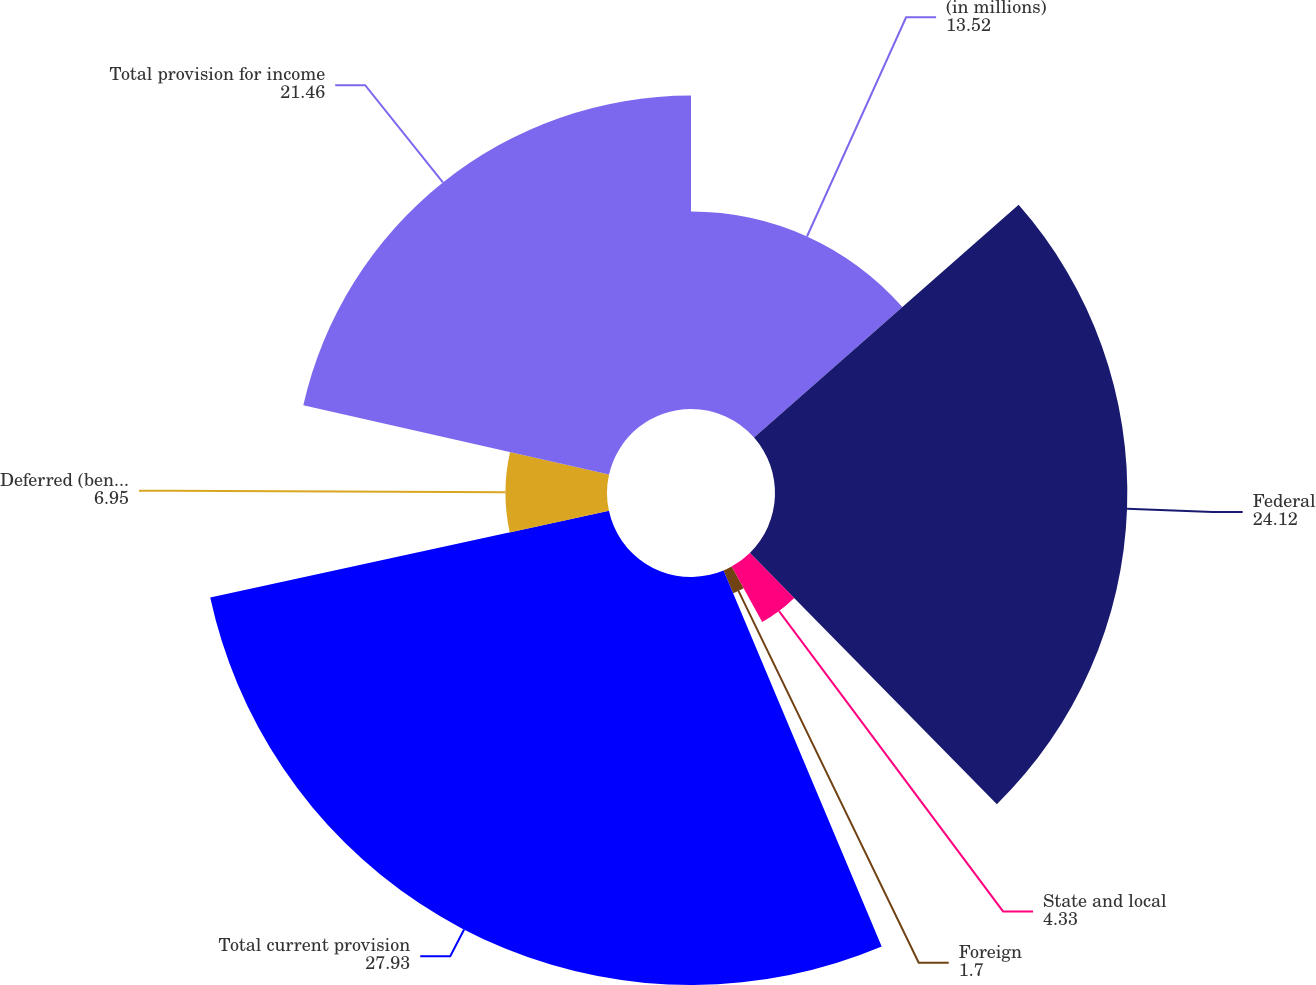Convert chart to OTSL. <chart><loc_0><loc_0><loc_500><loc_500><pie_chart><fcel>(in millions)<fcel>Federal<fcel>State and local<fcel>Foreign<fcel>Total current provision<fcel>Deferred (benefit) provision<fcel>Total provision for income<nl><fcel>13.52%<fcel>24.12%<fcel>4.33%<fcel>1.7%<fcel>27.93%<fcel>6.95%<fcel>21.46%<nl></chart> 